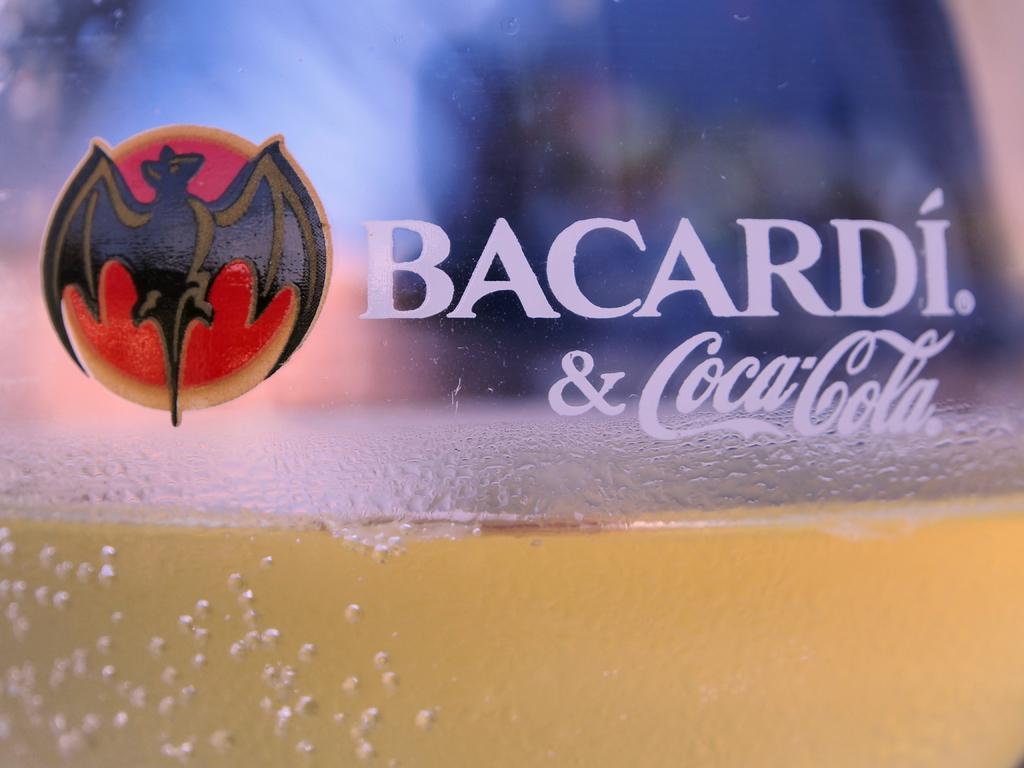What does this coca cola include?
Offer a terse response. Bacardi. What goes with bacardi here?
Your answer should be compact. Coca cola. 